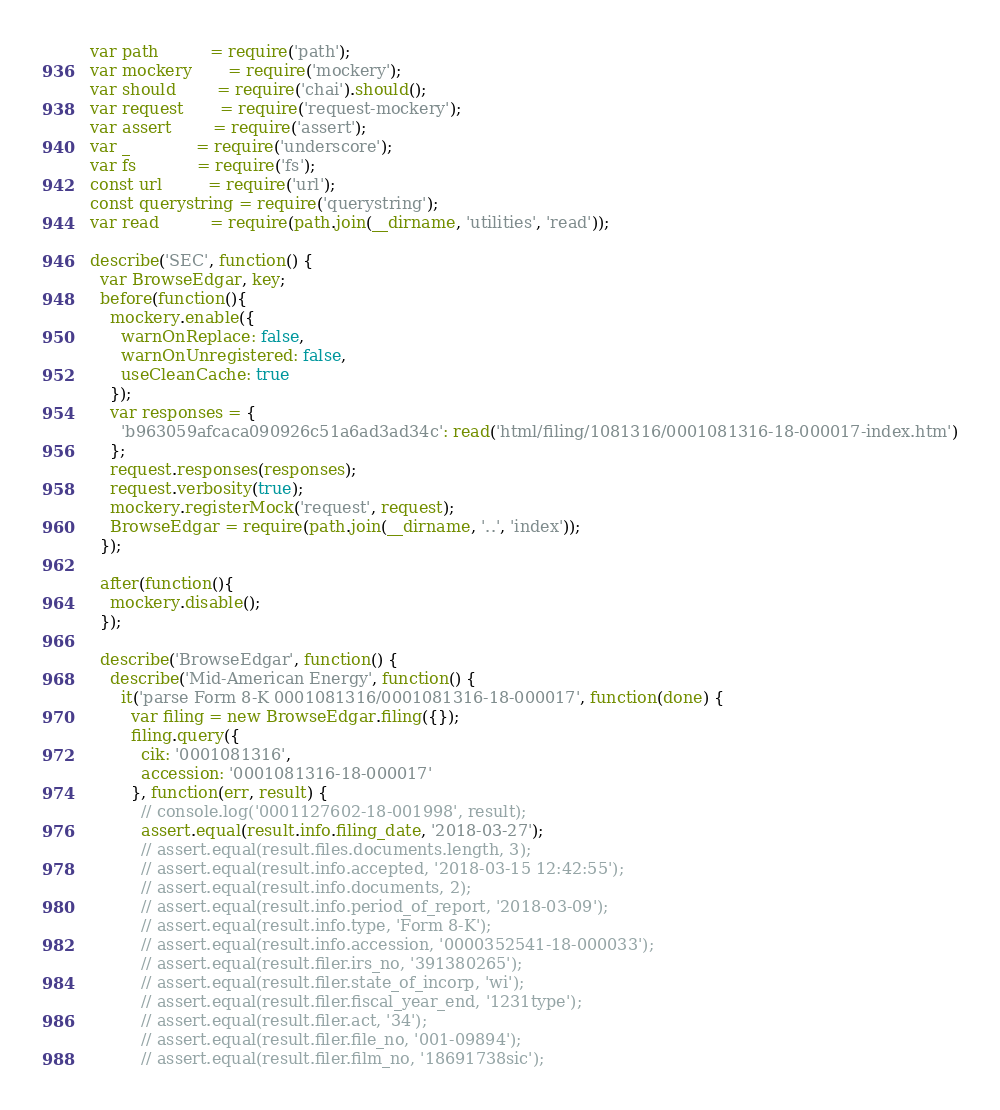Convert code to text. <code><loc_0><loc_0><loc_500><loc_500><_JavaScript_>var path          = require('path');
var mockery       = require('mockery');
var should        = require('chai').should();
var request       = require('request-mockery');
var assert        = require('assert');
var _             = require('underscore');
var fs            = require('fs');
const url         = require('url');
const querystring = require('querystring');
var read          = require(path.join(__dirname, 'utilities', 'read'));

describe('SEC', function() {
  var BrowseEdgar, key;
  before(function(){
    mockery.enable({
      warnOnReplace: false,
      warnOnUnregistered: false,
      useCleanCache: true
    });
    var responses = {
      'b963059afcaca090926c51a6ad3ad34c': read('html/filing/1081316/0001081316-18-000017-index.htm')
    };
    request.responses(responses);
    request.verbosity(true);
    mockery.registerMock('request', request);
    BrowseEdgar = require(path.join(__dirname, '..', 'index'));
  });

  after(function(){
    mockery.disable();
  }); 

  describe('BrowseEdgar', function() {
    describe('Mid-American Energy', function() { 
      it('parse Form 8-K 0001081316/0001081316-18-000017', function(done) {
        var filing = new BrowseEdgar.filing({});
        filing.query({
          cik: '0001081316', 
          accession: '0001081316-18-000017'
        }, function(err, result) {
          // console.log('0001127602-18-001998', result);
          assert.equal(result.info.filing_date, '2018-03-27');
          // assert.equal(result.files.documents.length, 3);
          // assert.equal(result.info.accepted, '2018-03-15 12:42:55');
          // assert.equal(result.info.documents, 2);
          // assert.equal(result.info.period_of_report, '2018-03-09');
          // assert.equal(result.info.type, 'Form 8-K');
          // assert.equal(result.info.accession, '0000352541-18-000033');
          // assert.equal(result.filer.irs_no, '391380265');
          // assert.equal(result.filer.state_of_incorp, 'wi');
          // assert.equal(result.filer.fiscal_year_end, '1231type');
          // assert.equal(result.filer.act, '34');
          // assert.equal(result.filer.file_no, '001-09894');
          // assert.equal(result.filer.film_no, '18691738sic');</code> 